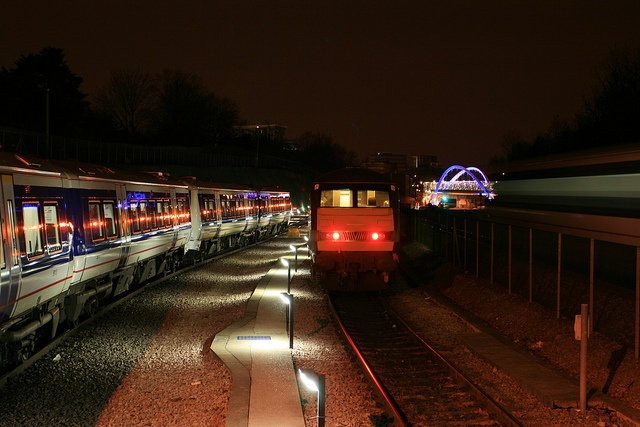Describe the objects in this image and their specific colors. I can see train in black, maroon, and gray tones and train in black, brown, maroon, and red tones in this image. 